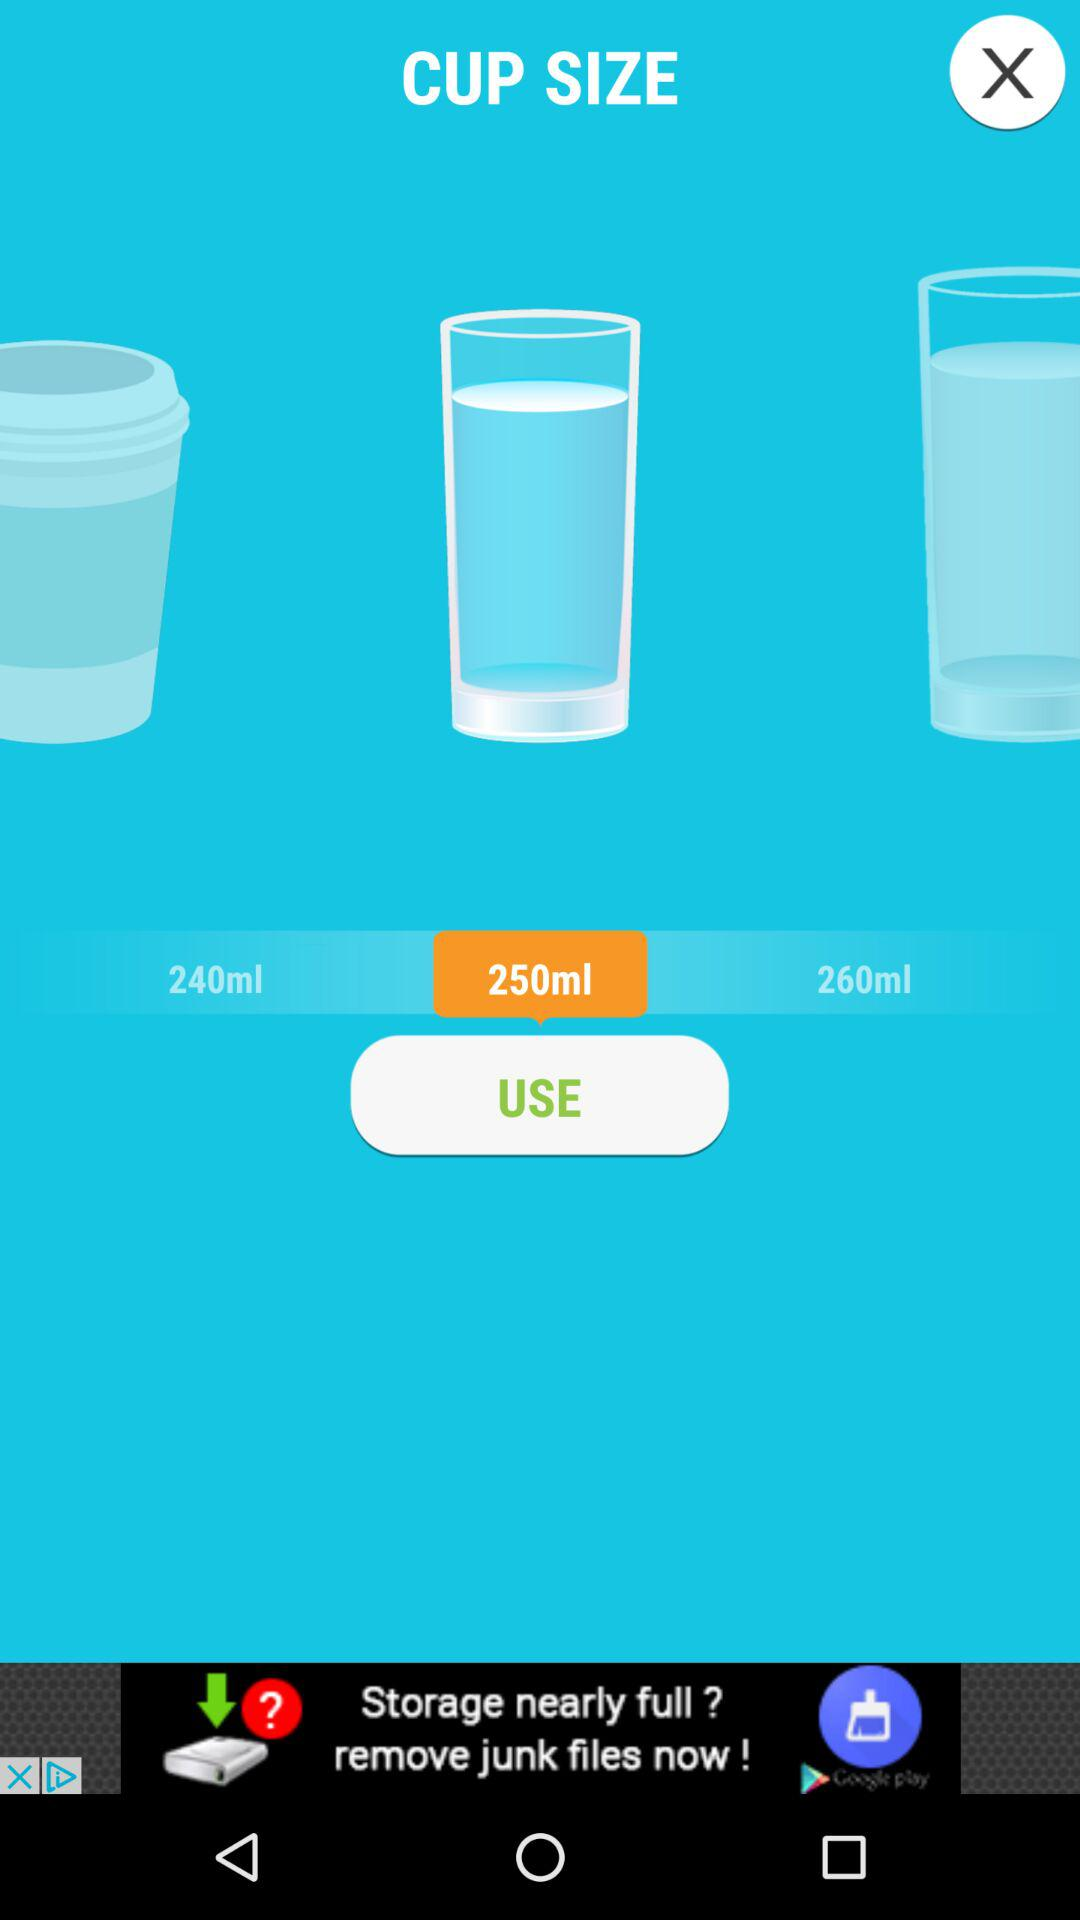What types of cup sizes are available? The sizes are "240ml", "250ml", and "260ml". 